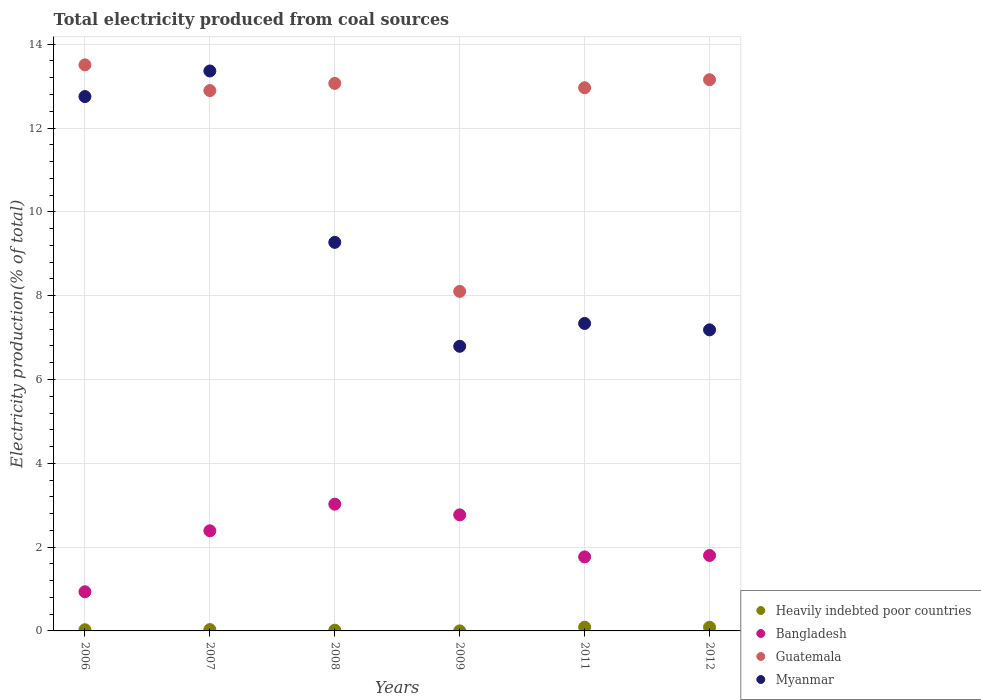How many different coloured dotlines are there?
Offer a terse response. 4. What is the total electricity produced in Guatemala in 2007?
Offer a terse response. 12.89. Across all years, what is the maximum total electricity produced in Guatemala?
Make the answer very short. 13.51. Across all years, what is the minimum total electricity produced in Bangladesh?
Your response must be concise. 0.93. In which year was the total electricity produced in Myanmar maximum?
Your response must be concise. 2007. In which year was the total electricity produced in Bangladesh minimum?
Offer a terse response. 2006. What is the total total electricity produced in Bangladesh in the graph?
Provide a short and direct response. 12.68. What is the difference between the total electricity produced in Guatemala in 2006 and that in 2009?
Provide a succinct answer. 5.41. What is the difference between the total electricity produced in Myanmar in 2007 and the total electricity produced in Guatemala in 2012?
Give a very brief answer. 0.21. What is the average total electricity produced in Heavily indebted poor countries per year?
Ensure brevity in your answer.  0.04. In the year 2007, what is the difference between the total electricity produced in Guatemala and total electricity produced in Myanmar?
Ensure brevity in your answer.  -0.47. What is the ratio of the total electricity produced in Guatemala in 2008 to that in 2012?
Make the answer very short. 0.99. What is the difference between the highest and the second highest total electricity produced in Myanmar?
Offer a terse response. 0.61. What is the difference between the highest and the lowest total electricity produced in Bangladesh?
Your answer should be very brief. 2.09. In how many years, is the total electricity produced in Myanmar greater than the average total electricity produced in Myanmar taken over all years?
Offer a terse response. 2. Is it the case that in every year, the sum of the total electricity produced in Myanmar and total electricity produced in Heavily indebted poor countries  is greater than the sum of total electricity produced in Bangladesh and total electricity produced in Guatemala?
Your response must be concise. No. Is it the case that in every year, the sum of the total electricity produced in Bangladesh and total electricity produced in Myanmar  is greater than the total electricity produced in Heavily indebted poor countries?
Your answer should be compact. Yes. Does the total electricity produced in Heavily indebted poor countries monotonically increase over the years?
Ensure brevity in your answer.  No. How many years are there in the graph?
Give a very brief answer. 6. How many legend labels are there?
Keep it short and to the point. 4. How are the legend labels stacked?
Provide a succinct answer. Vertical. What is the title of the graph?
Keep it short and to the point. Total electricity produced from coal sources. What is the label or title of the X-axis?
Offer a terse response. Years. What is the label or title of the Y-axis?
Make the answer very short. Electricity production(% of total). What is the Electricity production(% of total) in Heavily indebted poor countries in 2006?
Your answer should be compact. 0.03. What is the Electricity production(% of total) of Bangladesh in 2006?
Your response must be concise. 0.93. What is the Electricity production(% of total) in Guatemala in 2006?
Offer a very short reply. 13.51. What is the Electricity production(% of total) of Myanmar in 2006?
Your answer should be very brief. 12.75. What is the Electricity production(% of total) of Heavily indebted poor countries in 2007?
Provide a short and direct response. 0.03. What is the Electricity production(% of total) in Bangladesh in 2007?
Offer a terse response. 2.39. What is the Electricity production(% of total) of Guatemala in 2007?
Your answer should be compact. 12.89. What is the Electricity production(% of total) of Myanmar in 2007?
Your answer should be very brief. 13.36. What is the Electricity production(% of total) in Heavily indebted poor countries in 2008?
Offer a very short reply. 0.02. What is the Electricity production(% of total) of Bangladesh in 2008?
Give a very brief answer. 3.02. What is the Electricity production(% of total) of Guatemala in 2008?
Keep it short and to the point. 13.06. What is the Electricity production(% of total) of Myanmar in 2008?
Offer a terse response. 9.27. What is the Electricity production(% of total) of Heavily indebted poor countries in 2009?
Make the answer very short. 0. What is the Electricity production(% of total) in Bangladesh in 2009?
Your answer should be compact. 2.77. What is the Electricity production(% of total) of Guatemala in 2009?
Give a very brief answer. 8.1. What is the Electricity production(% of total) in Myanmar in 2009?
Provide a short and direct response. 6.79. What is the Electricity production(% of total) in Heavily indebted poor countries in 2011?
Provide a short and direct response. 0.09. What is the Electricity production(% of total) in Bangladesh in 2011?
Your answer should be compact. 1.77. What is the Electricity production(% of total) in Guatemala in 2011?
Your answer should be very brief. 12.96. What is the Electricity production(% of total) in Myanmar in 2011?
Offer a very short reply. 7.34. What is the Electricity production(% of total) in Heavily indebted poor countries in 2012?
Give a very brief answer. 0.09. What is the Electricity production(% of total) of Bangladesh in 2012?
Ensure brevity in your answer.  1.8. What is the Electricity production(% of total) in Guatemala in 2012?
Provide a succinct answer. 13.15. What is the Electricity production(% of total) of Myanmar in 2012?
Offer a terse response. 7.18. Across all years, what is the maximum Electricity production(% of total) in Heavily indebted poor countries?
Offer a very short reply. 0.09. Across all years, what is the maximum Electricity production(% of total) of Bangladesh?
Keep it short and to the point. 3.02. Across all years, what is the maximum Electricity production(% of total) of Guatemala?
Give a very brief answer. 13.51. Across all years, what is the maximum Electricity production(% of total) in Myanmar?
Offer a terse response. 13.36. Across all years, what is the minimum Electricity production(% of total) of Heavily indebted poor countries?
Provide a short and direct response. 0. Across all years, what is the minimum Electricity production(% of total) in Bangladesh?
Ensure brevity in your answer.  0.93. Across all years, what is the minimum Electricity production(% of total) of Guatemala?
Provide a succinct answer. 8.1. Across all years, what is the minimum Electricity production(% of total) of Myanmar?
Provide a succinct answer. 6.79. What is the total Electricity production(% of total) in Heavily indebted poor countries in the graph?
Keep it short and to the point. 0.25. What is the total Electricity production(% of total) in Bangladesh in the graph?
Offer a terse response. 12.68. What is the total Electricity production(% of total) in Guatemala in the graph?
Offer a very short reply. 73.68. What is the total Electricity production(% of total) in Myanmar in the graph?
Provide a short and direct response. 56.7. What is the difference between the Electricity production(% of total) in Heavily indebted poor countries in 2006 and that in 2007?
Make the answer very short. -0. What is the difference between the Electricity production(% of total) of Bangladesh in 2006 and that in 2007?
Your answer should be very brief. -1.46. What is the difference between the Electricity production(% of total) of Guatemala in 2006 and that in 2007?
Provide a succinct answer. 0.61. What is the difference between the Electricity production(% of total) of Myanmar in 2006 and that in 2007?
Offer a very short reply. -0.61. What is the difference between the Electricity production(% of total) in Heavily indebted poor countries in 2006 and that in 2008?
Offer a very short reply. 0.01. What is the difference between the Electricity production(% of total) of Bangladesh in 2006 and that in 2008?
Your response must be concise. -2.09. What is the difference between the Electricity production(% of total) of Guatemala in 2006 and that in 2008?
Your answer should be very brief. 0.44. What is the difference between the Electricity production(% of total) in Myanmar in 2006 and that in 2008?
Offer a terse response. 3.48. What is the difference between the Electricity production(% of total) in Heavily indebted poor countries in 2006 and that in 2009?
Your answer should be compact. 0.03. What is the difference between the Electricity production(% of total) in Bangladesh in 2006 and that in 2009?
Keep it short and to the point. -1.84. What is the difference between the Electricity production(% of total) of Guatemala in 2006 and that in 2009?
Your response must be concise. 5.41. What is the difference between the Electricity production(% of total) of Myanmar in 2006 and that in 2009?
Keep it short and to the point. 5.96. What is the difference between the Electricity production(% of total) in Heavily indebted poor countries in 2006 and that in 2011?
Your answer should be compact. -0.06. What is the difference between the Electricity production(% of total) of Bangladesh in 2006 and that in 2011?
Offer a terse response. -0.83. What is the difference between the Electricity production(% of total) in Guatemala in 2006 and that in 2011?
Give a very brief answer. 0.55. What is the difference between the Electricity production(% of total) in Myanmar in 2006 and that in 2011?
Make the answer very short. 5.41. What is the difference between the Electricity production(% of total) in Heavily indebted poor countries in 2006 and that in 2012?
Provide a succinct answer. -0.06. What is the difference between the Electricity production(% of total) of Bangladesh in 2006 and that in 2012?
Ensure brevity in your answer.  -0.87. What is the difference between the Electricity production(% of total) in Guatemala in 2006 and that in 2012?
Provide a short and direct response. 0.35. What is the difference between the Electricity production(% of total) in Myanmar in 2006 and that in 2012?
Offer a terse response. 5.57. What is the difference between the Electricity production(% of total) in Heavily indebted poor countries in 2007 and that in 2008?
Give a very brief answer. 0.02. What is the difference between the Electricity production(% of total) in Bangladesh in 2007 and that in 2008?
Your answer should be compact. -0.64. What is the difference between the Electricity production(% of total) in Guatemala in 2007 and that in 2008?
Keep it short and to the point. -0.17. What is the difference between the Electricity production(% of total) of Myanmar in 2007 and that in 2008?
Your answer should be very brief. 4.09. What is the difference between the Electricity production(% of total) of Heavily indebted poor countries in 2007 and that in 2009?
Your answer should be compact. 0.03. What is the difference between the Electricity production(% of total) in Bangladesh in 2007 and that in 2009?
Give a very brief answer. -0.38. What is the difference between the Electricity production(% of total) of Guatemala in 2007 and that in 2009?
Give a very brief answer. 4.79. What is the difference between the Electricity production(% of total) in Myanmar in 2007 and that in 2009?
Your answer should be compact. 6.57. What is the difference between the Electricity production(% of total) of Heavily indebted poor countries in 2007 and that in 2011?
Give a very brief answer. -0.06. What is the difference between the Electricity production(% of total) of Bangladesh in 2007 and that in 2011?
Provide a succinct answer. 0.62. What is the difference between the Electricity production(% of total) of Guatemala in 2007 and that in 2011?
Your response must be concise. -0.07. What is the difference between the Electricity production(% of total) in Myanmar in 2007 and that in 2011?
Ensure brevity in your answer.  6.02. What is the difference between the Electricity production(% of total) of Heavily indebted poor countries in 2007 and that in 2012?
Your response must be concise. -0.06. What is the difference between the Electricity production(% of total) of Bangladesh in 2007 and that in 2012?
Your answer should be compact. 0.59. What is the difference between the Electricity production(% of total) in Guatemala in 2007 and that in 2012?
Offer a very short reply. -0.26. What is the difference between the Electricity production(% of total) of Myanmar in 2007 and that in 2012?
Make the answer very short. 6.18. What is the difference between the Electricity production(% of total) of Heavily indebted poor countries in 2008 and that in 2009?
Provide a succinct answer. 0.02. What is the difference between the Electricity production(% of total) of Bangladesh in 2008 and that in 2009?
Make the answer very short. 0.25. What is the difference between the Electricity production(% of total) in Guatemala in 2008 and that in 2009?
Your response must be concise. 4.96. What is the difference between the Electricity production(% of total) in Myanmar in 2008 and that in 2009?
Provide a short and direct response. 2.48. What is the difference between the Electricity production(% of total) in Heavily indebted poor countries in 2008 and that in 2011?
Give a very brief answer. -0.07. What is the difference between the Electricity production(% of total) in Bangladesh in 2008 and that in 2011?
Provide a short and direct response. 1.26. What is the difference between the Electricity production(% of total) of Guatemala in 2008 and that in 2011?
Ensure brevity in your answer.  0.1. What is the difference between the Electricity production(% of total) of Myanmar in 2008 and that in 2011?
Your answer should be very brief. 1.94. What is the difference between the Electricity production(% of total) of Heavily indebted poor countries in 2008 and that in 2012?
Offer a very short reply. -0.07. What is the difference between the Electricity production(% of total) in Bangladesh in 2008 and that in 2012?
Ensure brevity in your answer.  1.22. What is the difference between the Electricity production(% of total) in Guatemala in 2008 and that in 2012?
Make the answer very short. -0.09. What is the difference between the Electricity production(% of total) of Myanmar in 2008 and that in 2012?
Your answer should be very brief. 2.09. What is the difference between the Electricity production(% of total) in Heavily indebted poor countries in 2009 and that in 2011?
Keep it short and to the point. -0.09. What is the difference between the Electricity production(% of total) of Guatemala in 2009 and that in 2011?
Make the answer very short. -4.86. What is the difference between the Electricity production(% of total) of Myanmar in 2009 and that in 2011?
Provide a short and direct response. -0.54. What is the difference between the Electricity production(% of total) in Heavily indebted poor countries in 2009 and that in 2012?
Ensure brevity in your answer.  -0.09. What is the difference between the Electricity production(% of total) in Bangladesh in 2009 and that in 2012?
Offer a very short reply. 0.97. What is the difference between the Electricity production(% of total) of Guatemala in 2009 and that in 2012?
Provide a short and direct response. -5.05. What is the difference between the Electricity production(% of total) of Myanmar in 2009 and that in 2012?
Offer a very short reply. -0.39. What is the difference between the Electricity production(% of total) of Heavily indebted poor countries in 2011 and that in 2012?
Make the answer very short. 0. What is the difference between the Electricity production(% of total) in Bangladesh in 2011 and that in 2012?
Your answer should be compact. -0.03. What is the difference between the Electricity production(% of total) of Guatemala in 2011 and that in 2012?
Give a very brief answer. -0.19. What is the difference between the Electricity production(% of total) of Myanmar in 2011 and that in 2012?
Your answer should be very brief. 0.15. What is the difference between the Electricity production(% of total) in Heavily indebted poor countries in 2006 and the Electricity production(% of total) in Bangladesh in 2007?
Your answer should be very brief. -2.36. What is the difference between the Electricity production(% of total) of Heavily indebted poor countries in 2006 and the Electricity production(% of total) of Guatemala in 2007?
Provide a short and direct response. -12.87. What is the difference between the Electricity production(% of total) of Heavily indebted poor countries in 2006 and the Electricity production(% of total) of Myanmar in 2007?
Your answer should be compact. -13.33. What is the difference between the Electricity production(% of total) in Bangladesh in 2006 and the Electricity production(% of total) in Guatemala in 2007?
Make the answer very short. -11.96. What is the difference between the Electricity production(% of total) of Bangladesh in 2006 and the Electricity production(% of total) of Myanmar in 2007?
Your answer should be very brief. -12.43. What is the difference between the Electricity production(% of total) of Guatemala in 2006 and the Electricity production(% of total) of Myanmar in 2007?
Keep it short and to the point. 0.15. What is the difference between the Electricity production(% of total) of Heavily indebted poor countries in 2006 and the Electricity production(% of total) of Bangladesh in 2008?
Provide a succinct answer. -3. What is the difference between the Electricity production(% of total) in Heavily indebted poor countries in 2006 and the Electricity production(% of total) in Guatemala in 2008?
Offer a very short reply. -13.04. What is the difference between the Electricity production(% of total) of Heavily indebted poor countries in 2006 and the Electricity production(% of total) of Myanmar in 2008?
Your answer should be compact. -9.24. What is the difference between the Electricity production(% of total) in Bangladesh in 2006 and the Electricity production(% of total) in Guatemala in 2008?
Give a very brief answer. -12.13. What is the difference between the Electricity production(% of total) in Bangladesh in 2006 and the Electricity production(% of total) in Myanmar in 2008?
Offer a terse response. -8.34. What is the difference between the Electricity production(% of total) in Guatemala in 2006 and the Electricity production(% of total) in Myanmar in 2008?
Your response must be concise. 4.24. What is the difference between the Electricity production(% of total) of Heavily indebted poor countries in 2006 and the Electricity production(% of total) of Bangladesh in 2009?
Ensure brevity in your answer.  -2.74. What is the difference between the Electricity production(% of total) of Heavily indebted poor countries in 2006 and the Electricity production(% of total) of Guatemala in 2009?
Your answer should be compact. -8.07. What is the difference between the Electricity production(% of total) of Heavily indebted poor countries in 2006 and the Electricity production(% of total) of Myanmar in 2009?
Give a very brief answer. -6.76. What is the difference between the Electricity production(% of total) in Bangladesh in 2006 and the Electricity production(% of total) in Guatemala in 2009?
Your answer should be very brief. -7.17. What is the difference between the Electricity production(% of total) of Bangladesh in 2006 and the Electricity production(% of total) of Myanmar in 2009?
Keep it short and to the point. -5.86. What is the difference between the Electricity production(% of total) of Guatemala in 2006 and the Electricity production(% of total) of Myanmar in 2009?
Offer a terse response. 6.72. What is the difference between the Electricity production(% of total) in Heavily indebted poor countries in 2006 and the Electricity production(% of total) in Bangladesh in 2011?
Ensure brevity in your answer.  -1.74. What is the difference between the Electricity production(% of total) of Heavily indebted poor countries in 2006 and the Electricity production(% of total) of Guatemala in 2011?
Your answer should be very brief. -12.93. What is the difference between the Electricity production(% of total) of Heavily indebted poor countries in 2006 and the Electricity production(% of total) of Myanmar in 2011?
Your answer should be very brief. -7.31. What is the difference between the Electricity production(% of total) of Bangladesh in 2006 and the Electricity production(% of total) of Guatemala in 2011?
Offer a very short reply. -12.03. What is the difference between the Electricity production(% of total) in Bangladesh in 2006 and the Electricity production(% of total) in Myanmar in 2011?
Keep it short and to the point. -6.4. What is the difference between the Electricity production(% of total) of Guatemala in 2006 and the Electricity production(% of total) of Myanmar in 2011?
Your answer should be very brief. 6.17. What is the difference between the Electricity production(% of total) of Heavily indebted poor countries in 2006 and the Electricity production(% of total) of Bangladesh in 2012?
Your answer should be very brief. -1.77. What is the difference between the Electricity production(% of total) in Heavily indebted poor countries in 2006 and the Electricity production(% of total) in Guatemala in 2012?
Your answer should be very brief. -13.13. What is the difference between the Electricity production(% of total) of Heavily indebted poor countries in 2006 and the Electricity production(% of total) of Myanmar in 2012?
Provide a short and direct response. -7.16. What is the difference between the Electricity production(% of total) of Bangladesh in 2006 and the Electricity production(% of total) of Guatemala in 2012?
Offer a terse response. -12.22. What is the difference between the Electricity production(% of total) of Bangladesh in 2006 and the Electricity production(% of total) of Myanmar in 2012?
Keep it short and to the point. -6.25. What is the difference between the Electricity production(% of total) in Guatemala in 2006 and the Electricity production(% of total) in Myanmar in 2012?
Keep it short and to the point. 6.32. What is the difference between the Electricity production(% of total) of Heavily indebted poor countries in 2007 and the Electricity production(% of total) of Bangladesh in 2008?
Provide a succinct answer. -2.99. What is the difference between the Electricity production(% of total) of Heavily indebted poor countries in 2007 and the Electricity production(% of total) of Guatemala in 2008?
Make the answer very short. -13.03. What is the difference between the Electricity production(% of total) in Heavily indebted poor countries in 2007 and the Electricity production(% of total) in Myanmar in 2008?
Your answer should be very brief. -9.24. What is the difference between the Electricity production(% of total) of Bangladesh in 2007 and the Electricity production(% of total) of Guatemala in 2008?
Your answer should be very brief. -10.68. What is the difference between the Electricity production(% of total) in Bangladesh in 2007 and the Electricity production(% of total) in Myanmar in 2008?
Your answer should be very brief. -6.88. What is the difference between the Electricity production(% of total) of Guatemala in 2007 and the Electricity production(% of total) of Myanmar in 2008?
Make the answer very short. 3.62. What is the difference between the Electricity production(% of total) of Heavily indebted poor countries in 2007 and the Electricity production(% of total) of Bangladesh in 2009?
Provide a short and direct response. -2.74. What is the difference between the Electricity production(% of total) of Heavily indebted poor countries in 2007 and the Electricity production(% of total) of Guatemala in 2009?
Offer a very short reply. -8.07. What is the difference between the Electricity production(% of total) in Heavily indebted poor countries in 2007 and the Electricity production(% of total) in Myanmar in 2009?
Make the answer very short. -6.76. What is the difference between the Electricity production(% of total) of Bangladesh in 2007 and the Electricity production(% of total) of Guatemala in 2009?
Provide a succinct answer. -5.71. What is the difference between the Electricity production(% of total) in Bangladesh in 2007 and the Electricity production(% of total) in Myanmar in 2009?
Your answer should be very brief. -4.4. What is the difference between the Electricity production(% of total) of Guatemala in 2007 and the Electricity production(% of total) of Myanmar in 2009?
Offer a very short reply. 6.1. What is the difference between the Electricity production(% of total) in Heavily indebted poor countries in 2007 and the Electricity production(% of total) in Bangladesh in 2011?
Offer a very short reply. -1.73. What is the difference between the Electricity production(% of total) in Heavily indebted poor countries in 2007 and the Electricity production(% of total) in Guatemala in 2011?
Your answer should be compact. -12.93. What is the difference between the Electricity production(% of total) of Heavily indebted poor countries in 2007 and the Electricity production(% of total) of Myanmar in 2011?
Give a very brief answer. -7.3. What is the difference between the Electricity production(% of total) of Bangladesh in 2007 and the Electricity production(% of total) of Guatemala in 2011?
Your answer should be compact. -10.57. What is the difference between the Electricity production(% of total) in Bangladesh in 2007 and the Electricity production(% of total) in Myanmar in 2011?
Keep it short and to the point. -4.95. What is the difference between the Electricity production(% of total) of Guatemala in 2007 and the Electricity production(% of total) of Myanmar in 2011?
Give a very brief answer. 5.56. What is the difference between the Electricity production(% of total) of Heavily indebted poor countries in 2007 and the Electricity production(% of total) of Bangladesh in 2012?
Your answer should be very brief. -1.77. What is the difference between the Electricity production(% of total) of Heavily indebted poor countries in 2007 and the Electricity production(% of total) of Guatemala in 2012?
Offer a very short reply. -13.12. What is the difference between the Electricity production(% of total) of Heavily indebted poor countries in 2007 and the Electricity production(% of total) of Myanmar in 2012?
Ensure brevity in your answer.  -7.15. What is the difference between the Electricity production(% of total) of Bangladesh in 2007 and the Electricity production(% of total) of Guatemala in 2012?
Make the answer very short. -10.76. What is the difference between the Electricity production(% of total) in Bangladesh in 2007 and the Electricity production(% of total) in Myanmar in 2012?
Provide a short and direct response. -4.79. What is the difference between the Electricity production(% of total) of Guatemala in 2007 and the Electricity production(% of total) of Myanmar in 2012?
Make the answer very short. 5.71. What is the difference between the Electricity production(% of total) of Heavily indebted poor countries in 2008 and the Electricity production(% of total) of Bangladesh in 2009?
Offer a terse response. -2.75. What is the difference between the Electricity production(% of total) in Heavily indebted poor countries in 2008 and the Electricity production(% of total) in Guatemala in 2009?
Make the answer very short. -8.09. What is the difference between the Electricity production(% of total) of Heavily indebted poor countries in 2008 and the Electricity production(% of total) of Myanmar in 2009?
Your answer should be compact. -6.78. What is the difference between the Electricity production(% of total) of Bangladesh in 2008 and the Electricity production(% of total) of Guatemala in 2009?
Offer a terse response. -5.08. What is the difference between the Electricity production(% of total) of Bangladesh in 2008 and the Electricity production(% of total) of Myanmar in 2009?
Provide a short and direct response. -3.77. What is the difference between the Electricity production(% of total) in Guatemala in 2008 and the Electricity production(% of total) in Myanmar in 2009?
Your response must be concise. 6.27. What is the difference between the Electricity production(% of total) in Heavily indebted poor countries in 2008 and the Electricity production(% of total) in Bangladesh in 2011?
Keep it short and to the point. -1.75. What is the difference between the Electricity production(% of total) of Heavily indebted poor countries in 2008 and the Electricity production(% of total) of Guatemala in 2011?
Your answer should be compact. -12.94. What is the difference between the Electricity production(% of total) in Heavily indebted poor countries in 2008 and the Electricity production(% of total) in Myanmar in 2011?
Keep it short and to the point. -7.32. What is the difference between the Electricity production(% of total) of Bangladesh in 2008 and the Electricity production(% of total) of Guatemala in 2011?
Your response must be concise. -9.94. What is the difference between the Electricity production(% of total) of Bangladesh in 2008 and the Electricity production(% of total) of Myanmar in 2011?
Provide a short and direct response. -4.31. What is the difference between the Electricity production(% of total) of Guatemala in 2008 and the Electricity production(% of total) of Myanmar in 2011?
Offer a very short reply. 5.73. What is the difference between the Electricity production(% of total) of Heavily indebted poor countries in 2008 and the Electricity production(% of total) of Bangladesh in 2012?
Offer a terse response. -1.78. What is the difference between the Electricity production(% of total) of Heavily indebted poor countries in 2008 and the Electricity production(% of total) of Guatemala in 2012?
Give a very brief answer. -13.14. What is the difference between the Electricity production(% of total) in Heavily indebted poor countries in 2008 and the Electricity production(% of total) in Myanmar in 2012?
Offer a terse response. -7.17. What is the difference between the Electricity production(% of total) of Bangladesh in 2008 and the Electricity production(% of total) of Guatemala in 2012?
Your answer should be very brief. -10.13. What is the difference between the Electricity production(% of total) in Bangladesh in 2008 and the Electricity production(% of total) in Myanmar in 2012?
Make the answer very short. -4.16. What is the difference between the Electricity production(% of total) of Guatemala in 2008 and the Electricity production(% of total) of Myanmar in 2012?
Make the answer very short. 5.88. What is the difference between the Electricity production(% of total) of Heavily indebted poor countries in 2009 and the Electricity production(% of total) of Bangladesh in 2011?
Ensure brevity in your answer.  -1.77. What is the difference between the Electricity production(% of total) of Heavily indebted poor countries in 2009 and the Electricity production(% of total) of Guatemala in 2011?
Your response must be concise. -12.96. What is the difference between the Electricity production(% of total) of Heavily indebted poor countries in 2009 and the Electricity production(% of total) of Myanmar in 2011?
Your answer should be compact. -7.34. What is the difference between the Electricity production(% of total) of Bangladesh in 2009 and the Electricity production(% of total) of Guatemala in 2011?
Your answer should be compact. -10.19. What is the difference between the Electricity production(% of total) in Bangladesh in 2009 and the Electricity production(% of total) in Myanmar in 2011?
Provide a short and direct response. -4.57. What is the difference between the Electricity production(% of total) of Guatemala in 2009 and the Electricity production(% of total) of Myanmar in 2011?
Give a very brief answer. 0.77. What is the difference between the Electricity production(% of total) of Heavily indebted poor countries in 2009 and the Electricity production(% of total) of Bangladesh in 2012?
Give a very brief answer. -1.8. What is the difference between the Electricity production(% of total) in Heavily indebted poor countries in 2009 and the Electricity production(% of total) in Guatemala in 2012?
Provide a succinct answer. -13.15. What is the difference between the Electricity production(% of total) in Heavily indebted poor countries in 2009 and the Electricity production(% of total) in Myanmar in 2012?
Provide a succinct answer. -7.18. What is the difference between the Electricity production(% of total) of Bangladesh in 2009 and the Electricity production(% of total) of Guatemala in 2012?
Your answer should be very brief. -10.38. What is the difference between the Electricity production(% of total) in Bangladesh in 2009 and the Electricity production(% of total) in Myanmar in 2012?
Provide a succinct answer. -4.41. What is the difference between the Electricity production(% of total) in Guatemala in 2009 and the Electricity production(% of total) in Myanmar in 2012?
Ensure brevity in your answer.  0.92. What is the difference between the Electricity production(% of total) of Heavily indebted poor countries in 2011 and the Electricity production(% of total) of Bangladesh in 2012?
Ensure brevity in your answer.  -1.71. What is the difference between the Electricity production(% of total) in Heavily indebted poor countries in 2011 and the Electricity production(% of total) in Guatemala in 2012?
Keep it short and to the point. -13.06. What is the difference between the Electricity production(% of total) in Heavily indebted poor countries in 2011 and the Electricity production(% of total) in Myanmar in 2012?
Your answer should be very brief. -7.1. What is the difference between the Electricity production(% of total) of Bangladesh in 2011 and the Electricity production(% of total) of Guatemala in 2012?
Your answer should be compact. -11.39. What is the difference between the Electricity production(% of total) of Bangladesh in 2011 and the Electricity production(% of total) of Myanmar in 2012?
Make the answer very short. -5.42. What is the difference between the Electricity production(% of total) of Guatemala in 2011 and the Electricity production(% of total) of Myanmar in 2012?
Provide a succinct answer. 5.78. What is the average Electricity production(% of total) in Heavily indebted poor countries per year?
Make the answer very short. 0.04. What is the average Electricity production(% of total) of Bangladesh per year?
Offer a very short reply. 2.11. What is the average Electricity production(% of total) in Guatemala per year?
Offer a terse response. 12.28. What is the average Electricity production(% of total) in Myanmar per year?
Ensure brevity in your answer.  9.45. In the year 2006, what is the difference between the Electricity production(% of total) in Heavily indebted poor countries and Electricity production(% of total) in Bangladesh?
Give a very brief answer. -0.91. In the year 2006, what is the difference between the Electricity production(% of total) of Heavily indebted poor countries and Electricity production(% of total) of Guatemala?
Keep it short and to the point. -13.48. In the year 2006, what is the difference between the Electricity production(% of total) in Heavily indebted poor countries and Electricity production(% of total) in Myanmar?
Your answer should be very brief. -12.72. In the year 2006, what is the difference between the Electricity production(% of total) of Bangladesh and Electricity production(% of total) of Guatemala?
Your answer should be very brief. -12.57. In the year 2006, what is the difference between the Electricity production(% of total) in Bangladesh and Electricity production(% of total) in Myanmar?
Give a very brief answer. -11.82. In the year 2006, what is the difference between the Electricity production(% of total) in Guatemala and Electricity production(% of total) in Myanmar?
Ensure brevity in your answer.  0.76. In the year 2007, what is the difference between the Electricity production(% of total) in Heavily indebted poor countries and Electricity production(% of total) in Bangladesh?
Provide a succinct answer. -2.36. In the year 2007, what is the difference between the Electricity production(% of total) of Heavily indebted poor countries and Electricity production(% of total) of Guatemala?
Offer a terse response. -12.86. In the year 2007, what is the difference between the Electricity production(% of total) in Heavily indebted poor countries and Electricity production(% of total) in Myanmar?
Your response must be concise. -13.33. In the year 2007, what is the difference between the Electricity production(% of total) of Bangladesh and Electricity production(% of total) of Guatemala?
Give a very brief answer. -10.5. In the year 2007, what is the difference between the Electricity production(% of total) in Bangladesh and Electricity production(% of total) in Myanmar?
Your response must be concise. -10.97. In the year 2007, what is the difference between the Electricity production(% of total) in Guatemala and Electricity production(% of total) in Myanmar?
Offer a very short reply. -0.47. In the year 2008, what is the difference between the Electricity production(% of total) in Heavily indebted poor countries and Electricity production(% of total) in Bangladesh?
Your answer should be very brief. -3.01. In the year 2008, what is the difference between the Electricity production(% of total) of Heavily indebted poor countries and Electricity production(% of total) of Guatemala?
Provide a succinct answer. -13.05. In the year 2008, what is the difference between the Electricity production(% of total) of Heavily indebted poor countries and Electricity production(% of total) of Myanmar?
Your answer should be compact. -9.26. In the year 2008, what is the difference between the Electricity production(% of total) of Bangladesh and Electricity production(% of total) of Guatemala?
Give a very brief answer. -10.04. In the year 2008, what is the difference between the Electricity production(% of total) in Bangladesh and Electricity production(% of total) in Myanmar?
Provide a succinct answer. -6.25. In the year 2008, what is the difference between the Electricity production(% of total) of Guatemala and Electricity production(% of total) of Myanmar?
Make the answer very short. 3.79. In the year 2009, what is the difference between the Electricity production(% of total) in Heavily indebted poor countries and Electricity production(% of total) in Bangladesh?
Give a very brief answer. -2.77. In the year 2009, what is the difference between the Electricity production(% of total) in Heavily indebted poor countries and Electricity production(% of total) in Guatemala?
Provide a short and direct response. -8.1. In the year 2009, what is the difference between the Electricity production(% of total) in Heavily indebted poor countries and Electricity production(% of total) in Myanmar?
Provide a succinct answer. -6.79. In the year 2009, what is the difference between the Electricity production(% of total) of Bangladesh and Electricity production(% of total) of Guatemala?
Offer a very short reply. -5.33. In the year 2009, what is the difference between the Electricity production(% of total) in Bangladesh and Electricity production(% of total) in Myanmar?
Provide a succinct answer. -4.02. In the year 2009, what is the difference between the Electricity production(% of total) of Guatemala and Electricity production(% of total) of Myanmar?
Your response must be concise. 1.31. In the year 2011, what is the difference between the Electricity production(% of total) of Heavily indebted poor countries and Electricity production(% of total) of Bangladesh?
Ensure brevity in your answer.  -1.68. In the year 2011, what is the difference between the Electricity production(% of total) in Heavily indebted poor countries and Electricity production(% of total) in Guatemala?
Your answer should be compact. -12.87. In the year 2011, what is the difference between the Electricity production(% of total) of Heavily indebted poor countries and Electricity production(% of total) of Myanmar?
Provide a succinct answer. -7.25. In the year 2011, what is the difference between the Electricity production(% of total) of Bangladesh and Electricity production(% of total) of Guatemala?
Provide a short and direct response. -11.2. In the year 2011, what is the difference between the Electricity production(% of total) in Bangladesh and Electricity production(% of total) in Myanmar?
Make the answer very short. -5.57. In the year 2011, what is the difference between the Electricity production(% of total) of Guatemala and Electricity production(% of total) of Myanmar?
Offer a terse response. 5.62. In the year 2012, what is the difference between the Electricity production(% of total) in Heavily indebted poor countries and Electricity production(% of total) in Bangladesh?
Provide a succinct answer. -1.71. In the year 2012, what is the difference between the Electricity production(% of total) of Heavily indebted poor countries and Electricity production(% of total) of Guatemala?
Provide a succinct answer. -13.07. In the year 2012, what is the difference between the Electricity production(% of total) in Heavily indebted poor countries and Electricity production(% of total) in Myanmar?
Make the answer very short. -7.1. In the year 2012, what is the difference between the Electricity production(% of total) in Bangladesh and Electricity production(% of total) in Guatemala?
Ensure brevity in your answer.  -11.35. In the year 2012, what is the difference between the Electricity production(% of total) of Bangladesh and Electricity production(% of total) of Myanmar?
Offer a very short reply. -5.38. In the year 2012, what is the difference between the Electricity production(% of total) of Guatemala and Electricity production(% of total) of Myanmar?
Offer a very short reply. 5.97. What is the ratio of the Electricity production(% of total) in Heavily indebted poor countries in 2006 to that in 2007?
Ensure brevity in your answer.  0.87. What is the ratio of the Electricity production(% of total) in Bangladesh in 2006 to that in 2007?
Offer a very short reply. 0.39. What is the ratio of the Electricity production(% of total) in Guatemala in 2006 to that in 2007?
Your answer should be very brief. 1.05. What is the ratio of the Electricity production(% of total) in Myanmar in 2006 to that in 2007?
Provide a succinct answer. 0.95. What is the ratio of the Electricity production(% of total) of Heavily indebted poor countries in 2006 to that in 2008?
Offer a terse response. 1.64. What is the ratio of the Electricity production(% of total) of Bangladesh in 2006 to that in 2008?
Keep it short and to the point. 0.31. What is the ratio of the Electricity production(% of total) of Guatemala in 2006 to that in 2008?
Provide a succinct answer. 1.03. What is the ratio of the Electricity production(% of total) in Myanmar in 2006 to that in 2008?
Your response must be concise. 1.38. What is the ratio of the Electricity production(% of total) in Heavily indebted poor countries in 2006 to that in 2009?
Offer a terse response. 35.13. What is the ratio of the Electricity production(% of total) in Bangladesh in 2006 to that in 2009?
Give a very brief answer. 0.34. What is the ratio of the Electricity production(% of total) of Guatemala in 2006 to that in 2009?
Provide a short and direct response. 1.67. What is the ratio of the Electricity production(% of total) of Myanmar in 2006 to that in 2009?
Ensure brevity in your answer.  1.88. What is the ratio of the Electricity production(% of total) in Heavily indebted poor countries in 2006 to that in 2011?
Offer a terse response. 0.31. What is the ratio of the Electricity production(% of total) in Bangladesh in 2006 to that in 2011?
Ensure brevity in your answer.  0.53. What is the ratio of the Electricity production(% of total) in Guatemala in 2006 to that in 2011?
Give a very brief answer. 1.04. What is the ratio of the Electricity production(% of total) in Myanmar in 2006 to that in 2011?
Offer a terse response. 1.74. What is the ratio of the Electricity production(% of total) of Heavily indebted poor countries in 2006 to that in 2012?
Provide a short and direct response. 0.32. What is the ratio of the Electricity production(% of total) of Bangladesh in 2006 to that in 2012?
Provide a short and direct response. 0.52. What is the ratio of the Electricity production(% of total) in Guatemala in 2006 to that in 2012?
Keep it short and to the point. 1.03. What is the ratio of the Electricity production(% of total) in Myanmar in 2006 to that in 2012?
Your answer should be very brief. 1.77. What is the ratio of the Electricity production(% of total) of Heavily indebted poor countries in 2007 to that in 2008?
Ensure brevity in your answer.  1.9. What is the ratio of the Electricity production(% of total) of Bangladesh in 2007 to that in 2008?
Give a very brief answer. 0.79. What is the ratio of the Electricity production(% of total) in Guatemala in 2007 to that in 2008?
Provide a succinct answer. 0.99. What is the ratio of the Electricity production(% of total) in Myanmar in 2007 to that in 2008?
Provide a short and direct response. 1.44. What is the ratio of the Electricity production(% of total) in Heavily indebted poor countries in 2007 to that in 2009?
Make the answer very short. 40.55. What is the ratio of the Electricity production(% of total) in Bangladesh in 2007 to that in 2009?
Provide a succinct answer. 0.86. What is the ratio of the Electricity production(% of total) of Guatemala in 2007 to that in 2009?
Make the answer very short. 1.59. What is the ratio of the Electricity production(% of total) in Myanmar in 2007 to that in 2009?
Your answer should be very brief. 1.97. What is the ratio of the Electricity production(% of total) of Heavily indebted poor countries in 2007 to that in 2011?
Give a very brief answer. 0.36. What is the ratio of the Electricity production(% of total) of Bangladesh in 2007 to that in 2011?
Your answer should be very brief. 1.35. What is the ratio of the Electricity production(% of total) in Guatemala in 2007 to that in 2011?
Your response must be concise. 0.99. What is the ratio of the Electricity production(% of total) in Myanmar in 2007 to that in 2011?
Ensure brevity in your answer.  1.82. What is the ratio of the Electricity production(% of total) of Heavily indebted poor countries in 2007 to that in 2012?
Give a very brief answer. 0.37. What is the ratio of the Electricity production(% of total) of Bangladesh in 2007 to that in 2012?
Your answer should be very brief. 1.33. What is the ratio of the Electricity production(% of total) in Guatemala in 2007 to that in 2012?
Your response must be concise. 0.98. What is the ratio of the Electricity production(% of total) of Myanmar in 2007 to that in 2012?
Offer a terse response. 1.86. What is the ratio of the Electricity production(% of total) in Heavily indebted poor countries in 2008 to that in 2009?
Your answer should be very brief. 21.39. What is the ratio of the Electricity production(% of total) of Bangladesh in 2008 to that in 2009?
Provide a short and direct response. 1.09. What is the ratio of the Electricity production(% of total) of Guatemala in 2008 to that in 2009?
Provide a succinct answer. 1.61. What is the ratio of the Electricity production(% of total) of Myanmar in 2008 to that in 2009?
Offer a very short reply. 1.37. What is the ratio of the Electricity production(% of total) of Heavily indebted poor countries in 2008 to that in 2011?
Ensure brevity in your answer.  0.19. What is the ratio of the Electricity production(% of total) in Bangladesh in 2008 to that in 2011?
Offer a terse response. 1.71. What is the ratio of the Electricity production(% of total) of Guatemala in 2008 to that in 2011?
Your answer should be very brief. 1.01. What is the ratio of the Electricity production(% of total) of Myanmar in 2008 to that in 2011?
Offer a very short reply. 1.26. What is the ratio of the Electricity production(% of total) of Heavily indebted poor countries in 2008 to that in 2012?
Keep it short and to the point. 0.2. What is the ratio of the Electricity production(% of total) of Bangladesh in 2008 to that in 2012?
Your response must be concise. 1.68. What is the ratio of the Electricity production(% of total) in Guatemala in 2008 to that in 2012?
Offer a very short reply. 0.99. What is the ratio of the Electricity production(% of total) in Myanmar in 2008 to that in 2012?
Ensure brevity in your answer.  1.29. What is the ratio of the Electricity production(% of total) in Heavily indebted poor countries in 2009 to that in 2011?
Give a very brief answer. 0.01. What is the ratio of the Electricity production(% of total) in Bangladesh in 2009 to that in 2011?
Offer a very short reply. 1.57. What is the ratio of the Electricity production(% of total) of Guatemala in 2009 to that in 2011?
Offer a very short reply. 0.63. What is the ratio of the Electricity production(% of total) of Myanmar in 2009 to that in 2011?
Your answer should be compact. 0.93. What is the ratio of the Electricity production(% of total) of Heavily indebted poor countries in 2009 to that in 2012?
Keep it short and to the point. 0.01. What is the ratio of the Electricity production(% of total) of Bangladesh in 2009 to that in 2012?
Your response must be concise. 1.54. What is the ratio of the Electricity production(% of total) of Guatemala in 2009 to that in 2012?
Provide a succinct answer. 0.62. What is the ratio of the Electricity production(% of total) of Myanmar in 2009 to that in 2012?
Give a very brief answer. 0.95. What is the ratio of the Electricity production(% of total) in Heavily indebted poor countries in 2011 to that in 2012?
Your response must be concise. 1.02. What is the ratio of the Electricity production(% of total) in Bangladesh in 2011 to that in 2012?
Ensure brevity in your answer.  0.98. What is the ratio of the Electricity production(% of total) of Guatemala in 2011 to that in 2012?
Keep it short and to the point. 0.99. What is the ratio of the Electricity production(% of total) in Myanmar in 2011 to that in 2012?
Offer a terse response. 1.02. What is the difference between the highest and the second highest Electricity production(% of total) in Heavily indebted poor countries?
Your response must be concise. 0. What is the difference between the highest and the second highest Electricity production(% of total) of Bangladesh?
Ensure brevity in your answer.  0.25. What is the difference between the highest and the second highest Electricity production(% of total) in Guatemala?
Offer a terse response. 0.35. What is the difference between the highest and the second highest Electricity production(% of total) in Myanmar?
Your answer should be compact. 0.61. What is the difference between the highest and the lowest Electricity production(% of total) in Heavily indebted poor countries?
Your answer should be very brief. 0.09. What is the difference between the highest and the lowest Electricity production(% of total) of Bangladesh?
Your answer should be compact. 2.09. What is the difference between the highest and the lowest Electricity production(% of total) in Guatemala?
Ensure brevity in your answer.  5.41. What is the difference between the highest and the lowest Electricity production(% of total) of Myanmar?
Offer a terse response. 6.57. 